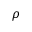<formula> <loc_0><loc_0><loc_500><loc_500>\rho</formula> 